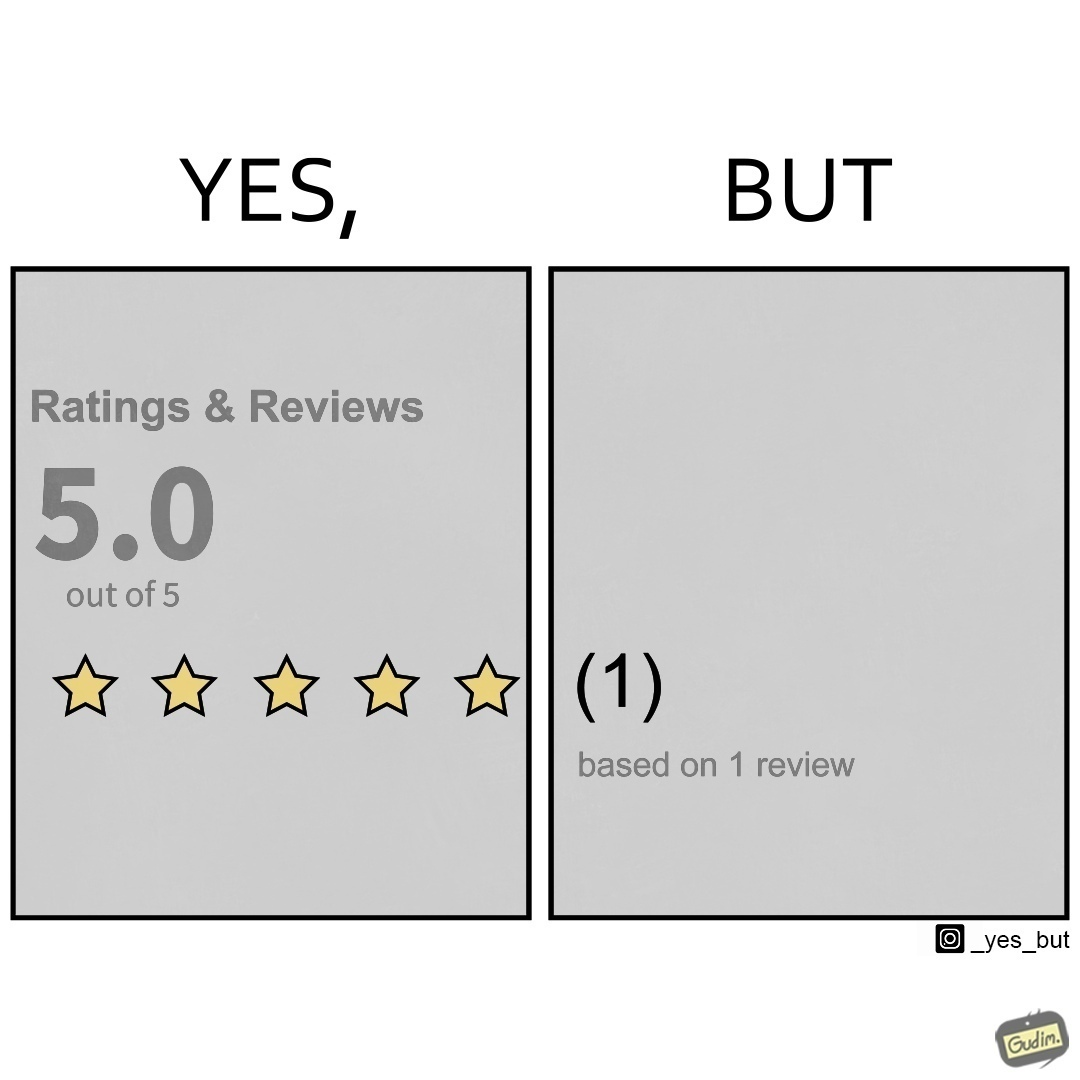Compare the left and right sides of this image. In the left part of the image: "Ratings and Reviews" showing that a product/service is rated 5 out of 5 stars. In the right part of the image: The rating is based on 1 review only 